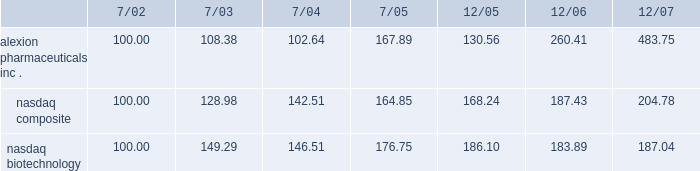The company 2019s stock performance the following graph compares cumulative total return of the company 2019s common stock with the cumulative total return of ( i ) the nasdaq stock market-united states , and ( ii ) the nasdaq biotechnology index .
The graph assumes ( a ) $ 100 was invested on july 31 , 2001 in each of the company 2019s common stock , the stocks comprising the nasdaq stock market-united states and the stocks comprising the nasdaq biotechnology index , and ( b ) the reinvestment of dividends .
Comparison of 65 month cumulative total return* among alexion pharmaceuticals , inc. , the nasdaq composite index and the nasdaq biotechnology index alexion pharmaceuticals , inc .
Nasdaq composite nasdaq biotechnology .

What is the difference between the percent change between 7/02 and 7/03 of the investments into axion and the nasdaq composite? 
Computations: (((108.38 - 100) / 100) - ((128.98 - 100) / 100))
Answer: -0.206. 